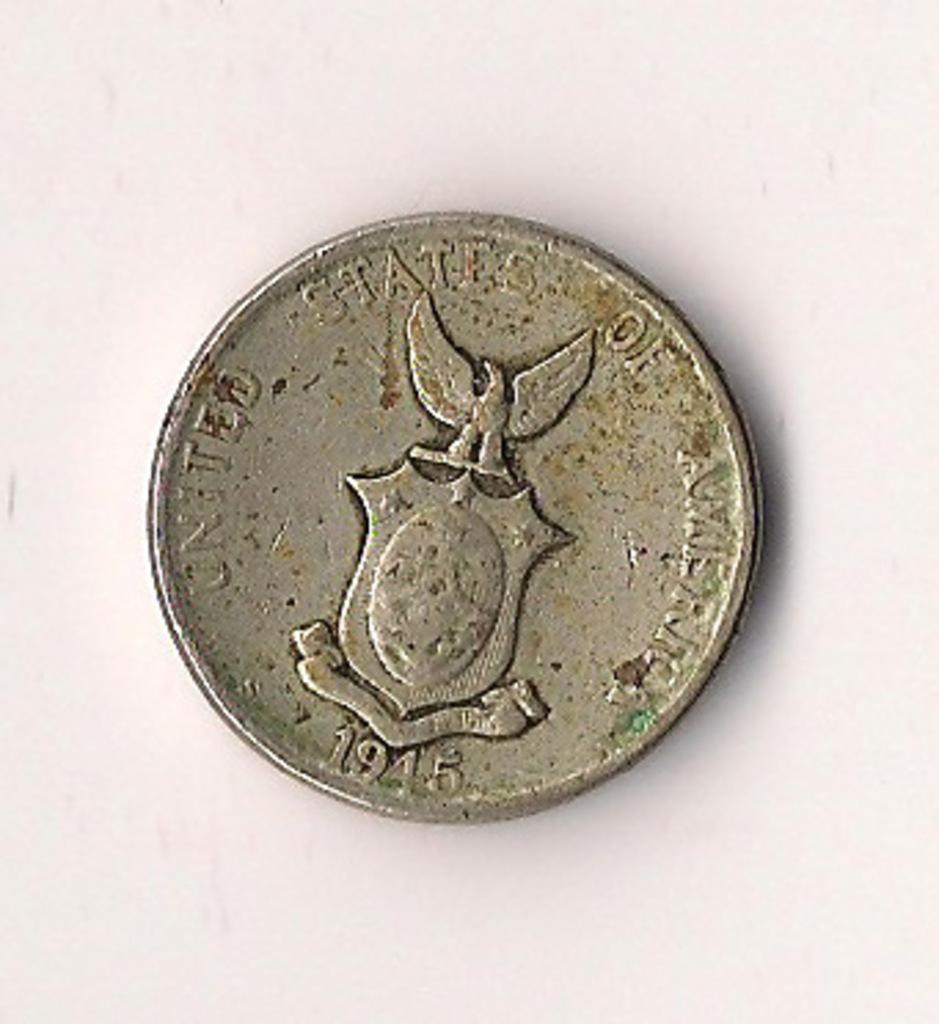Please provide a concise description of this image. In this image, we can see a silver coin with text, numerical numbers and symbol. This coin is placed on the white surface. 